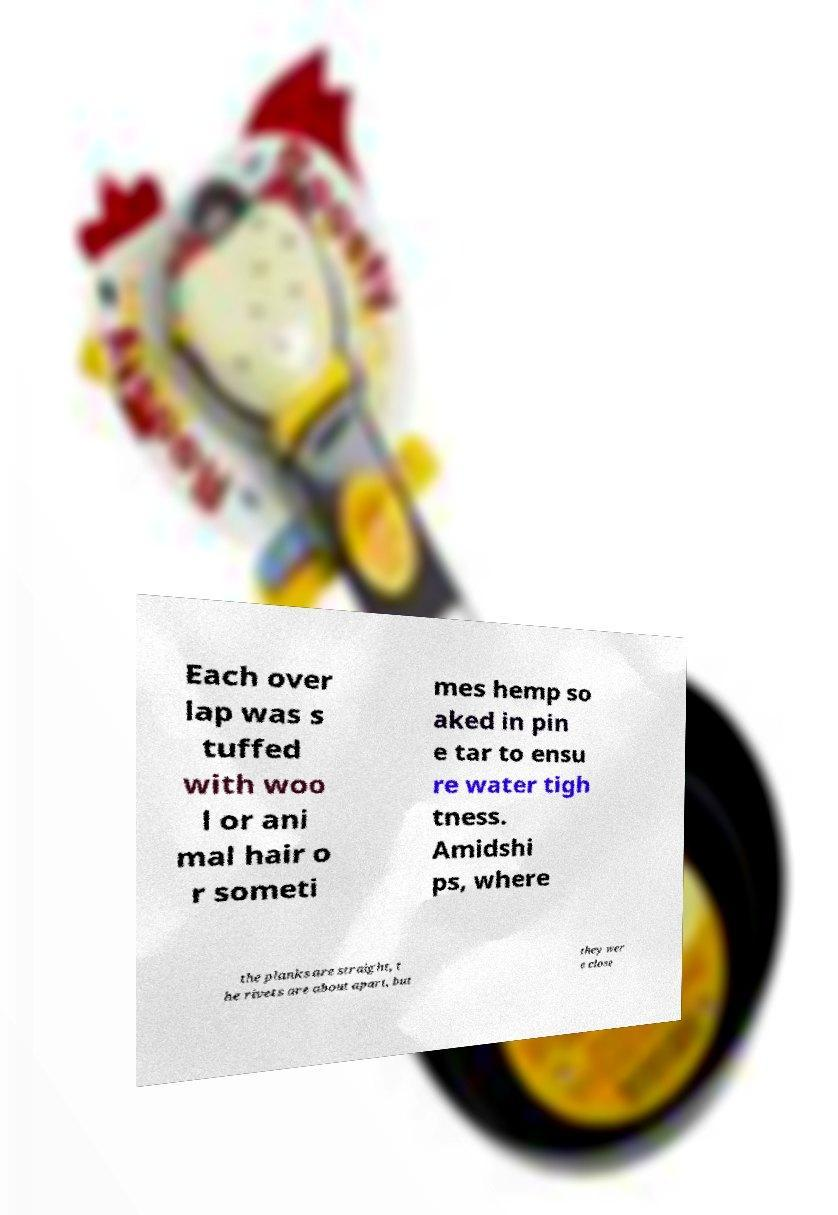Could you extract and type out the text from this image? Each over lap was s tuffed with woo l or ani mal hair o r someti mes hemp so aked in pin e tar to ensu re water tigh tness. Amidshi ps, where the planks are straight, t he rivets are about apart, but they wer e close 